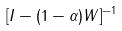<formula> <loc_0><loc_0><loc_500><loc_500>[ I - ( 1 - \alpha ) W ] ^ { - 1 }</formula> 